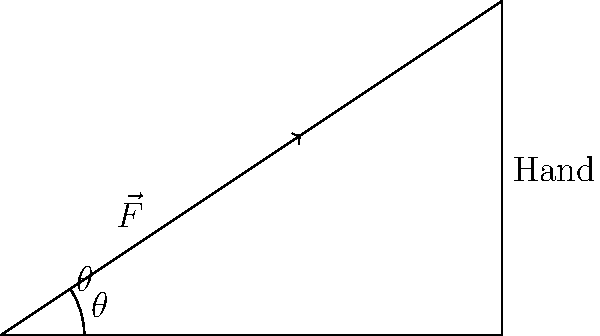As a retired doctor conducting hygiene workshops, you're explaining the optimal angle for hand washing. A force $\vec{F}$ of magnitude 10 N is applied to a hand at an angle $\theta$ from the horizontal. If the most effective cleansing occurs when the force perpendicular to the hand is maximized, and the hand is positioned at a 33.7° angle from the horizontal, what is the optimal angle $\theta$ for applying the force? To find the optimal angle $\theta$, we need to maximize the force perpendicular to the hand. Let's approach this step-by-step:

1) The hand is at a 33.7° angle from the horizontal. The vector perpendicular to the hand will be at 33.7° + 90° = 123.7° from the horizontal.

2) We want to maximize the projection of $\vec{F}$ onto this perpendicular vector. The projection is maximized when $\vec{F}$ is parallel to the perpendicular vector.

3) Therefore, the optimal angle $\theta$ should be equal to the angle of the perpendicular vector: 123.7°.

4) We can verify this using the vector projection formula:
   $F_{\perp} = |\vec{F}| \cos(\theta - 123.7°)$

5) When $\theta = 123.7°$, $\cos(\theta - 123.7°) = \cos(0°) = 1$, which gives the maximum possible projection.

Thus, the optimal angle $\theta$ for applying the force is 123.7° from the horizontal.
Answer: 123.7° 